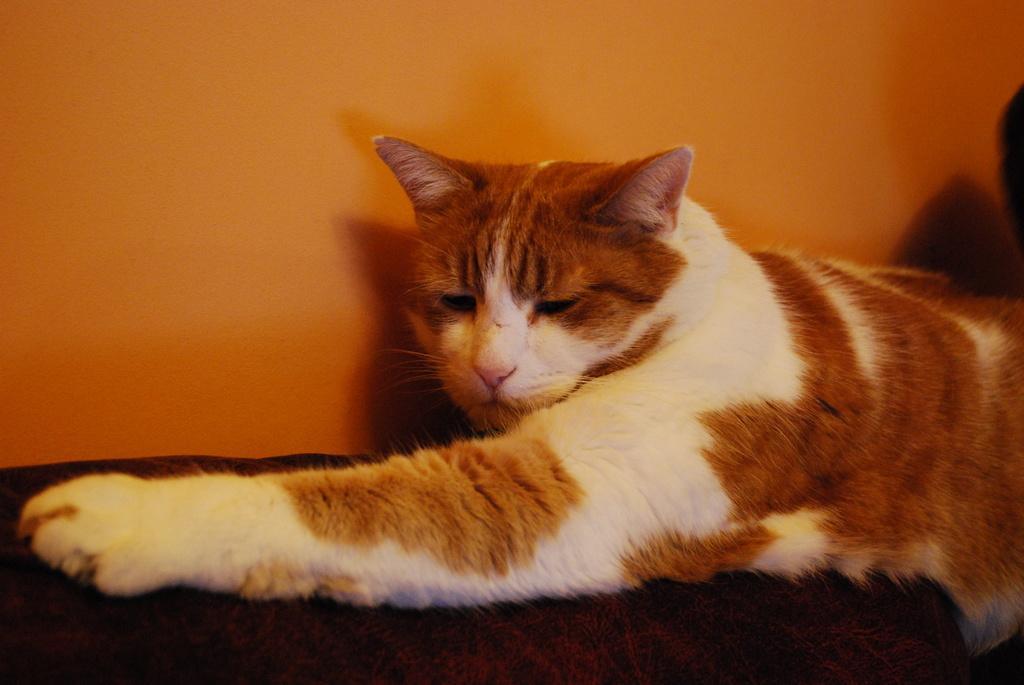Could you give a brief overview of what you see in this image? In this picture I can see there cat lying on the floor. It has a white and brown fur and there is a orange wall in the backdrop. 